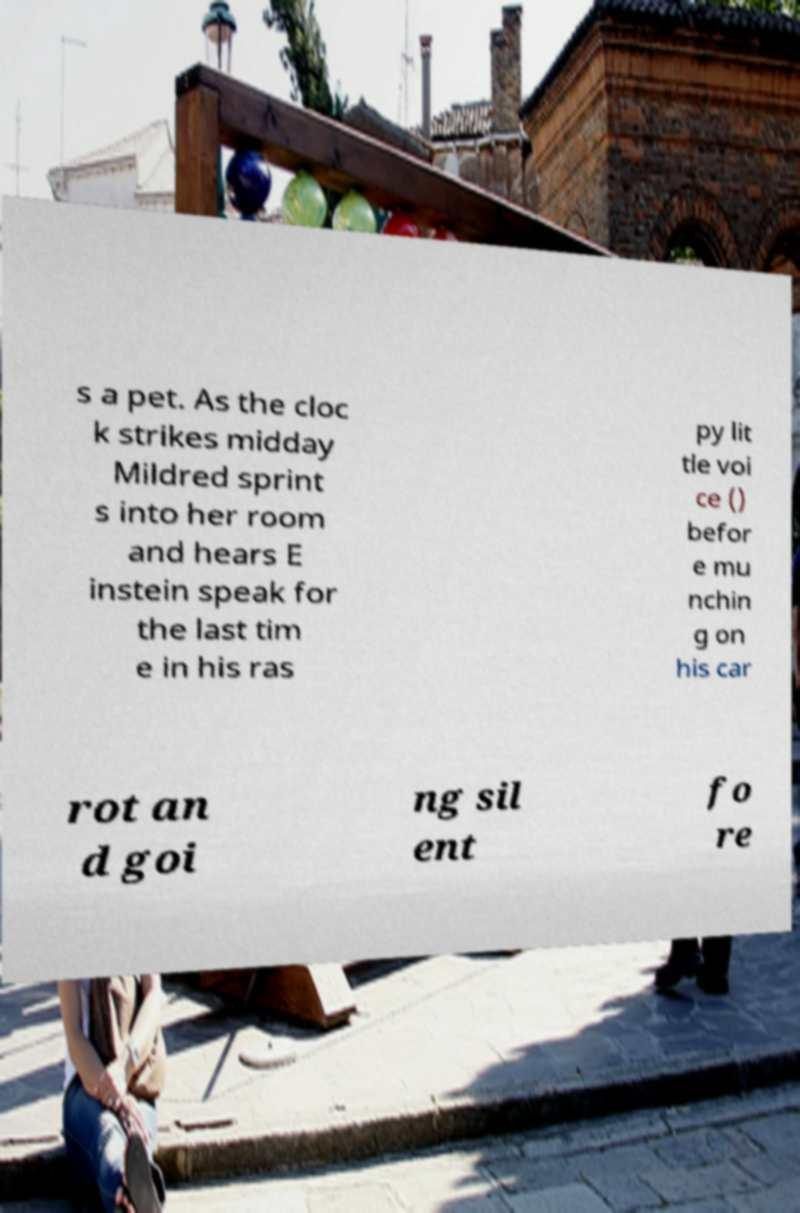Please identify and transcribe the text found in this image. s a pet. As the cloc k strikes midday Mildred sprint s into her room and hears E instein speak for the last tim e in his ras py lit tle voi ce () befor e mu nchin g on his car rot an d goi ng sil ent fo re 